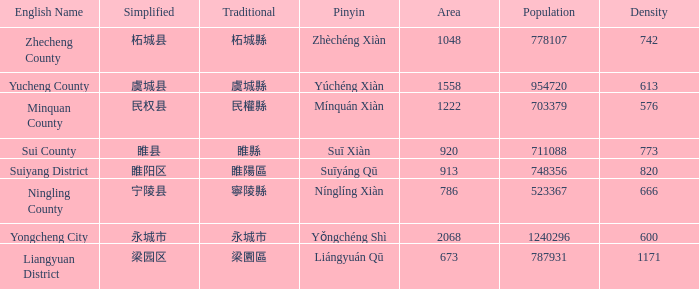How many areas have a population of 703379? 1.0. 